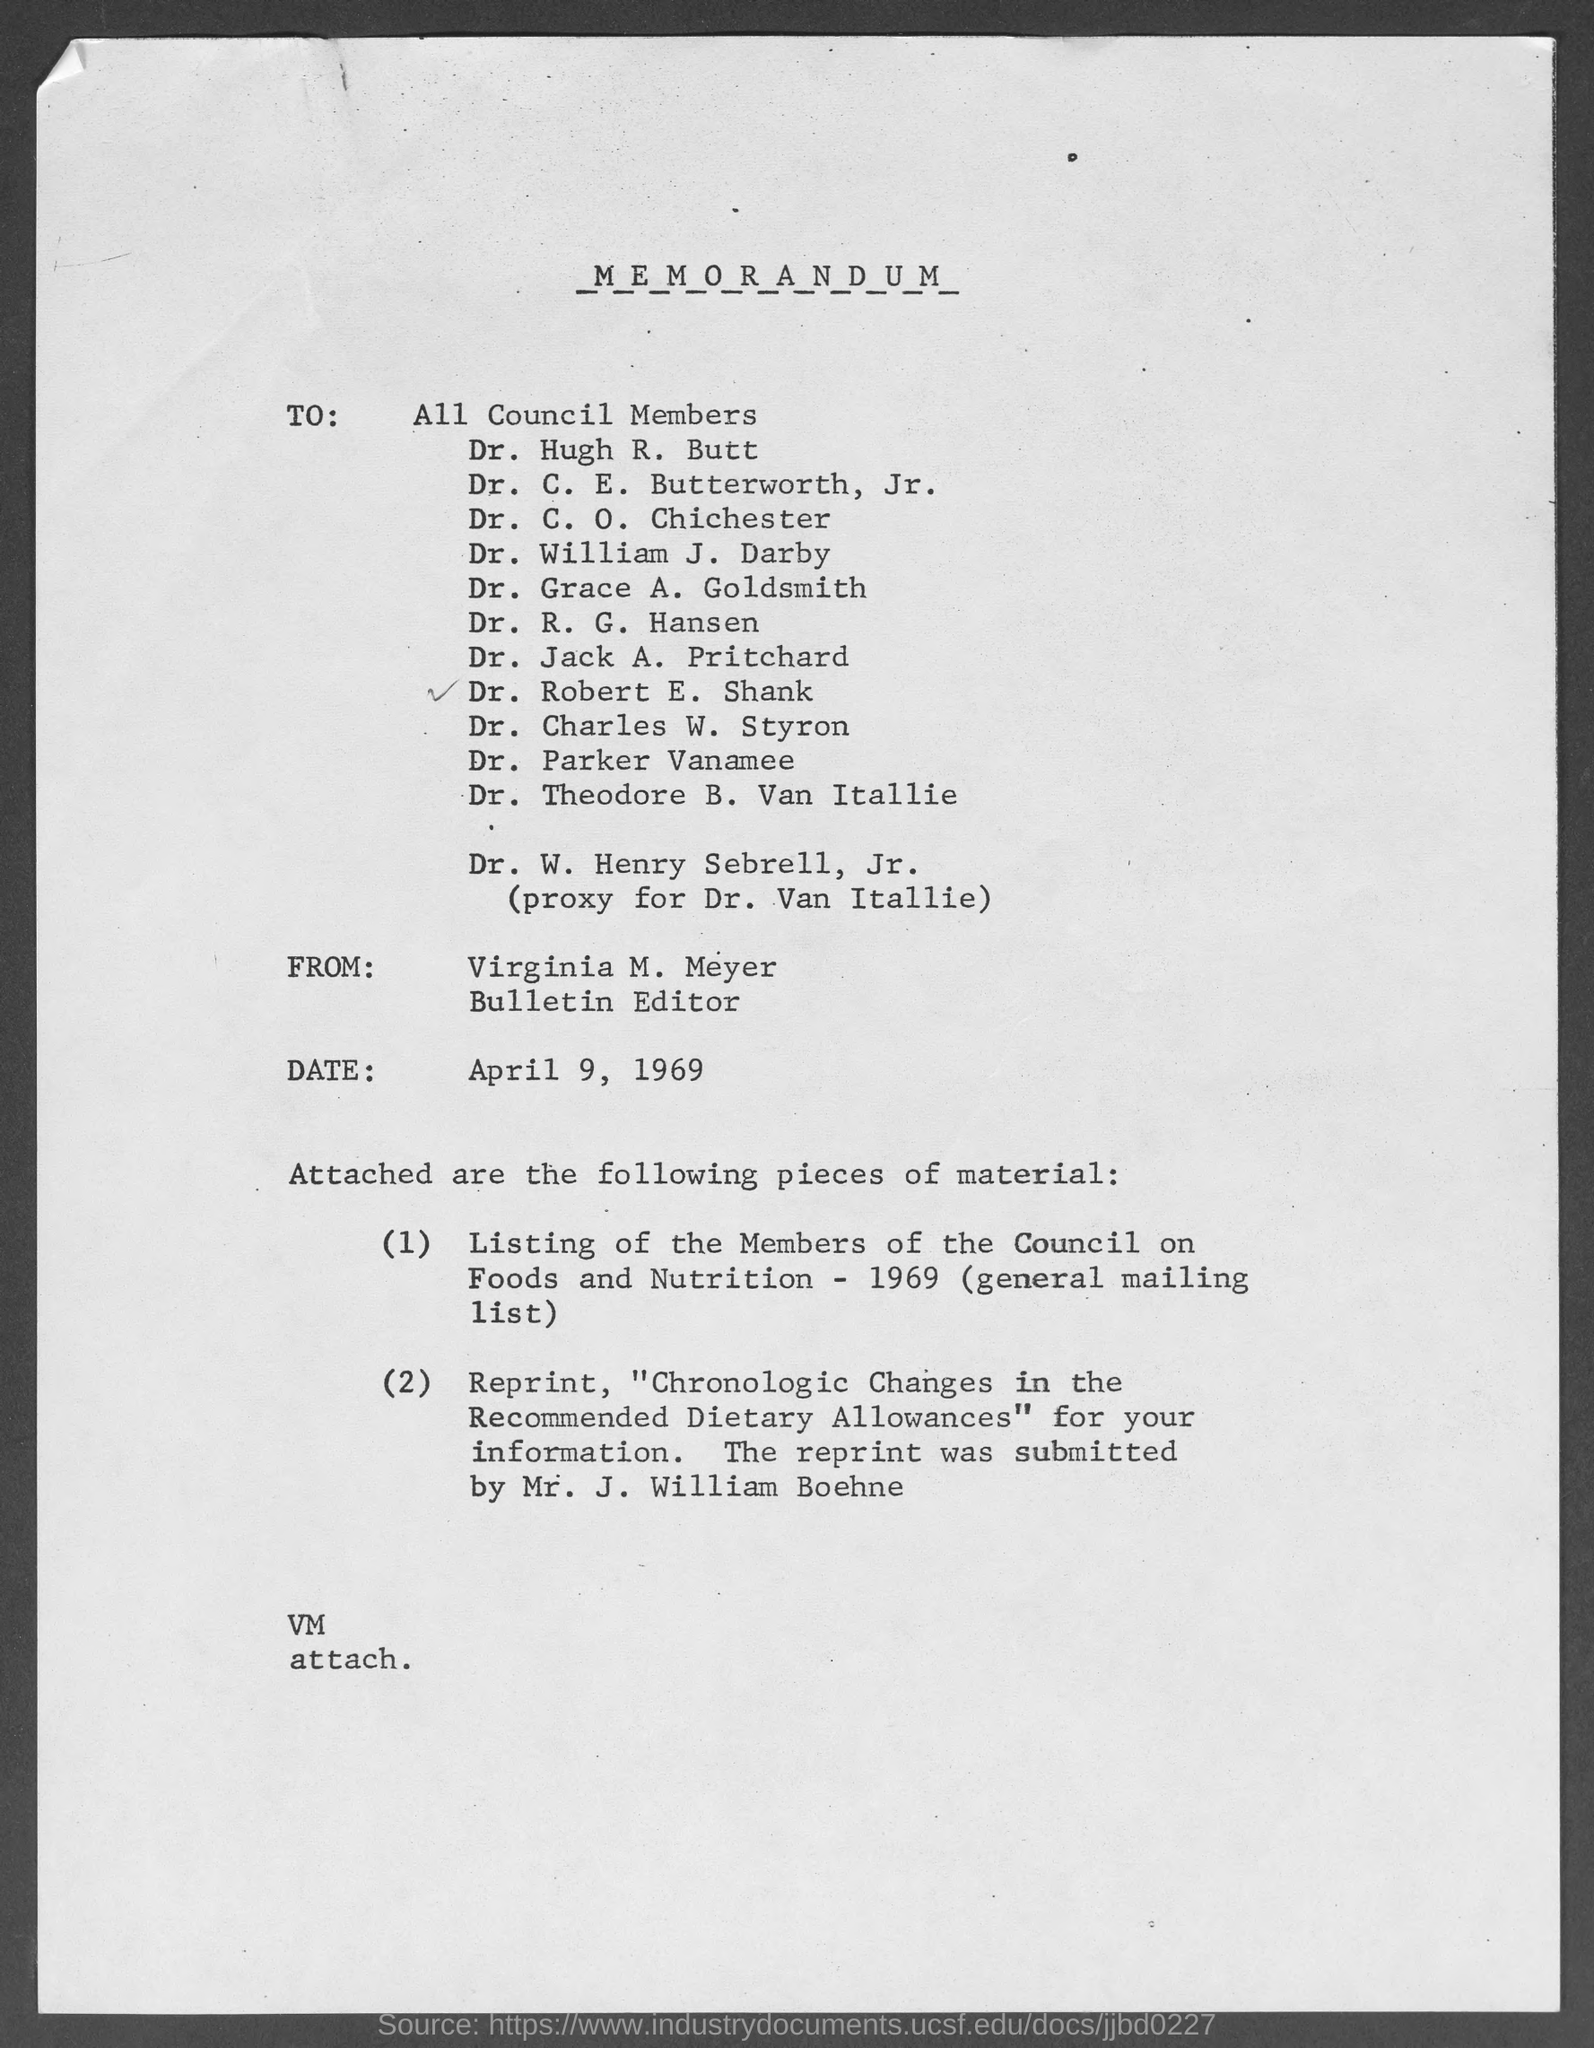Outline some significant characteristics in this image. The memorandum is dated April 9, 1969. The from address in a memorandum is Virginia M. Meyer. 